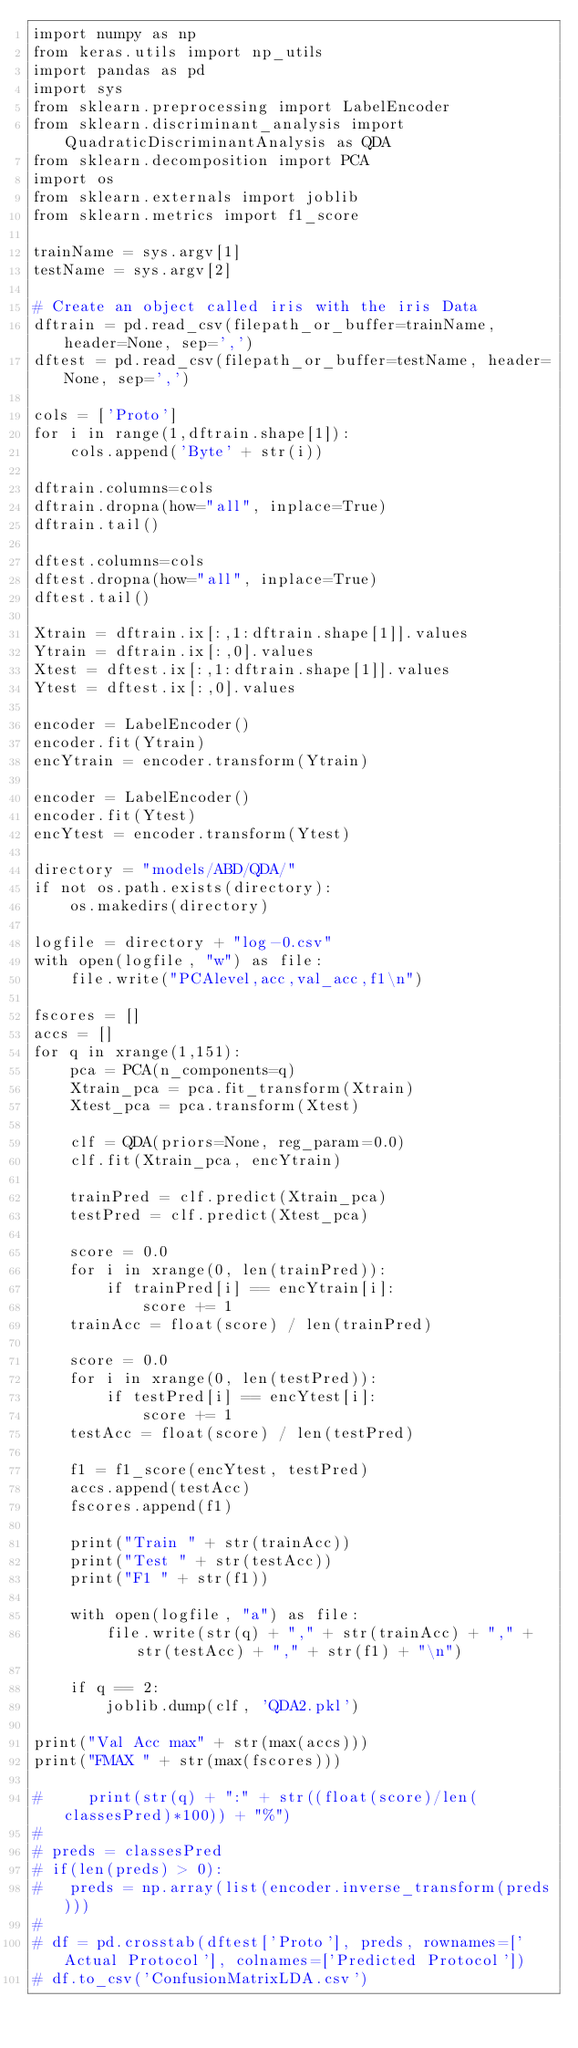Convert code to text. <code><loc_0><loc_0><loc_500><loc_500><_Python_>import numpy as np
from keras.utils import np_utils
import pandas as pd
import sys
from sklearn.preprocessing import LabelEncoder
from sklearn.discriminant_analysis import QuadraticDiscriminantAnalysis as QDA
from sklearn.decomposition import PCA
import os
from sklearn.externals import joblib
from sklearn.metrics import f1_score

trainName = sys.argv[1]
testName = sys.argv[2]

# Create an object called iris with the iris Data
dftrain = pd.read_csv(filepath_or_buffer=trainName, header=None, sep=',')
dftest = pd.read_csv(filepath_or_buffer=testName, header=None, sep=',')

cols = ['Proto']
for i in range(1,dftrain.shape[1]):
    cols.append('Byte' + str(i))

dftrain.columns=cols
dftrain.dropna(how="all", inplace=True)
dftrain.tail()

dftest.columns=cols
dftest.dropna(how="all", inplace=True)
dftest.tail()

Xtrain = dftrain.ix[:,1:dftrain.shape[1]].values
Ytrain = dftrain.ix[:,0].values
Xtest = dftest.ix[:,1:dftrain.shape[1]].values
Ytest = dftest.ix[:,0].values

encoder = LabelEncoder()
encoder.fit(Ytrain)
encYtrain = encoder.transform(Ytrain)

encoder = LabelEncoder()
encoder.fit(Ytest)
encYtest = encoder.transform(Ytest)

directory = "models/ABD/QDA/"
if not os.path.exists(directory):
    os.makedirs(directory)

logfile = directory + "log-0.csv"
with open(logfile, "w") as file:
    file.write("PCAlevel,acc,val_acc,f1\n")

fscores = []
accs = []
for q in xrange(1,151):
    pca = PCA(n_components=q)
    Xtrain_pca = pca.fit_transform(Xtrain)
    Xtest_pca = pca.transform(Xtest)

    clf = QDA(priors=None, reg_param=0.0)
    clf.fit(Xtrain_pca, encYtrain)

    trainPred = clf.predict(Xtrain_pca)
    testPred = clf.predict(Xtest_pca)

    score = 0.0
    for i in xrange(0, len(trainPred)):
        if trainPred[i] == encYtrain[i]:
            score += 1
    trainAcc = float(score) / len(trainPred)

    score = 0.0
    for i in xrange(0, len(testPred)):
        if testPred[i] == encYtest[i]:
            score += 1
    testAcc = float(score) / len(testPred)

    f1 = f1_score(encYtest, testPred)
    accs.append(testAcc)
    fscores.append(f1)

    print("Train " + str(trainAcc))
    print("Test " + str(testAcc))
    print("F1 " + str(f1))

    with open(logfile, "a") as file:
        file.write(str(q) + "," + str(trainAcc) + "," + str(testAcc) + "," + str(f1) + "\n")

    if q == 2:
        joblib.dump(clf, 'QDA2.pkl')

print("Val Acc max" + str(max(accs)))
print("FMAX " + str(max(fscores)))

#     print(str(q) + ":" + str((float(score)/len(classesPred)*100)) + "%")
#
# preds = classesPred
# if(len(preds) > 0):
# 	preds = np.array(list(encoder.inverse_transform(preds)))
#
# df = pd.crosstab(dftest['Proto'], preds, rownames=['Actual Protocol'], colnames=['Predicted Protocol'])
# df.to_csv('ConfusionMatrixLDA.csv')

</code> 